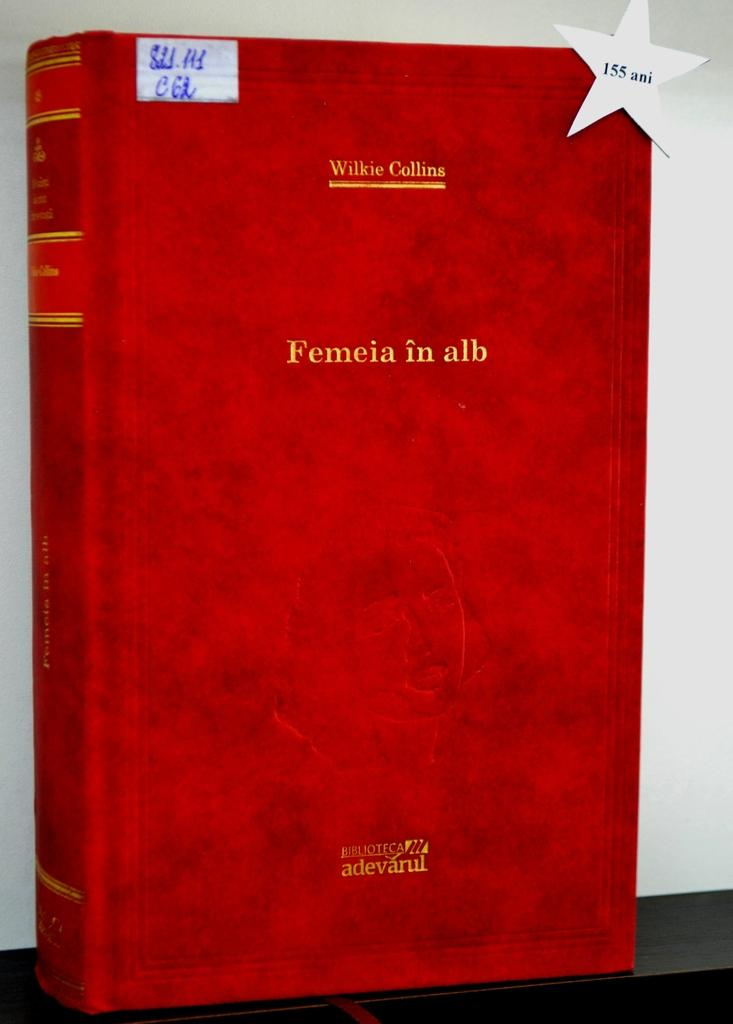Provide a one-sentence caption for the provided image. A red covered book has a title of, "Femeia in alb.". 